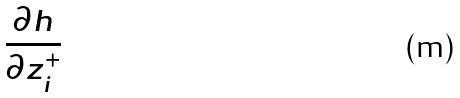Convert formula to latex. <formula><loc_0><loc_0><loc_500><loc_500>\frac { \partial h } { \partial z _ { i } ^ { + } }</formula> 